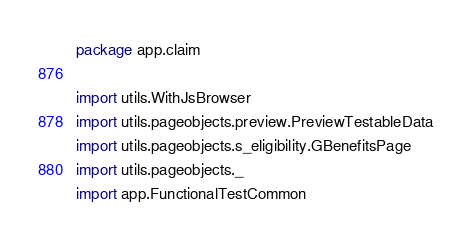<code> <loc_0><loc_0><loc_500><loc_500><_Scala_>package app.claim

import utils.WithJsBrowser
import utils.pageobjects.preview.PreviewTestableData
import utils.pageobjects.s_eligibility.GBenefitsPage
import utils.pageobjects._
import app.FunctionalTestCommon
</code> 